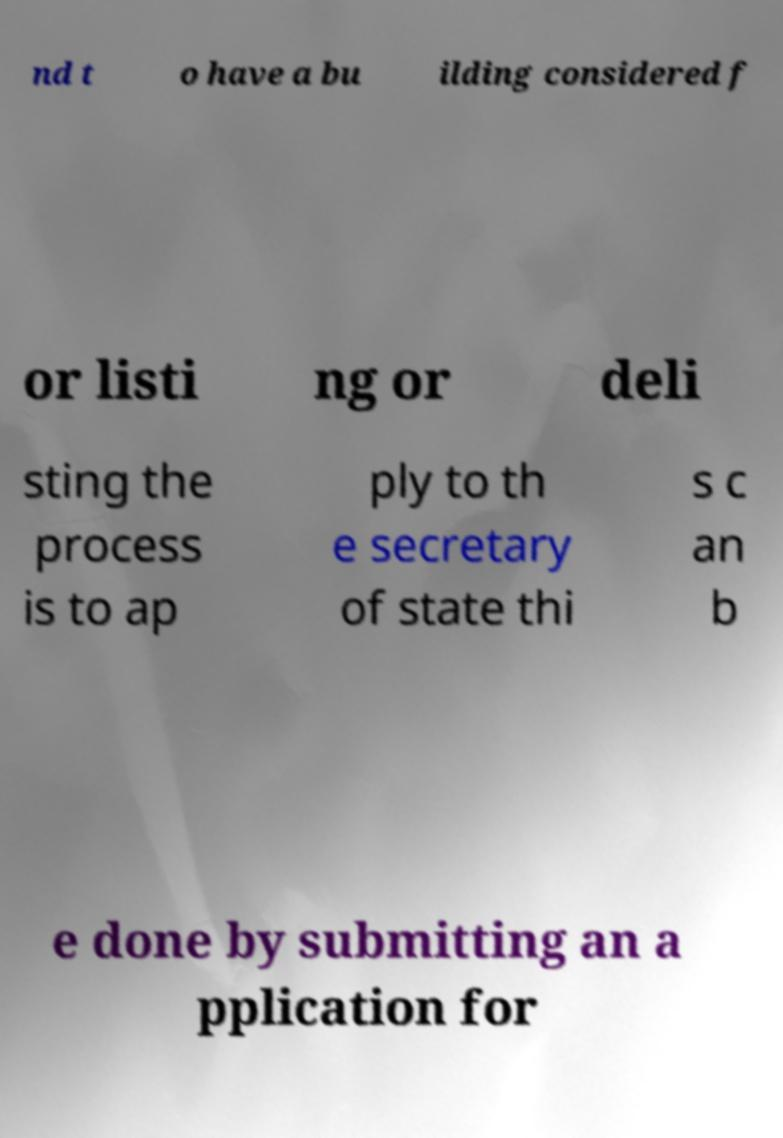Could you assist in decoding the text presented in this image and type it out clearly? nd t o have a bu ilding considered f or listi ng or deli sting the process is to ap ply to th e secretary of state thi s c an b e done by submitting an a pplication for 